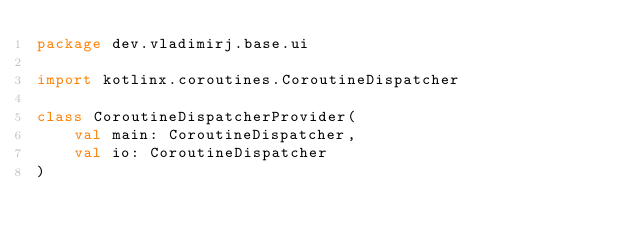Convert code to text. <code><loc_0><loc_0><loc_500><loc_500><_Kotlin_>package dev.vladimirj.base.ui

import kotlinx.coroutines.CoroutineDispatcher

class CoroutineDispatcherProvider(
    val main: CoroutineDispatcher,
    val io: CoroutineDispatcher
)</code> 